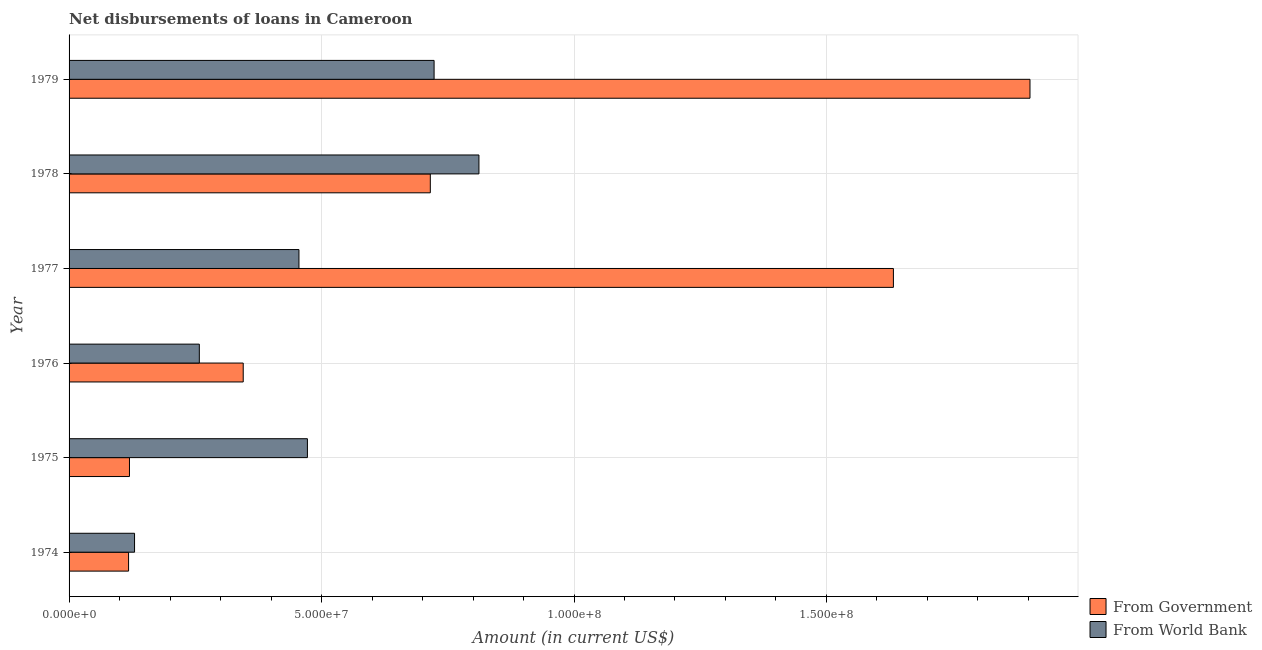How many groups of bars are there?
Provide a short and direct response. 6. Are the number of bars on each tick of the Y-axis equal?
Give a very brief answer. Yes. What is the label of the 1st group of bars from the top?
Your response must be concise. 1979. In how many cases, is the number of bars for a given year not equal to the number of legend labels?
Your answer should be very brief. 0. What is the net disbursements of loan from government in 1975?
Your answer should be compact. 1.20e+07. Across all years, what is the maximum net disbursements of loan from world bank?
Your response must be concise. 8.12e+07. Across all years, what is the minimum net disbursements of loan from government?
Offer a very short reply. 1.18e+07. In which year was the net disbursements of loan from world bank maximum?
Give a very brief answer. 1978. In which year was the net disbursements of loan from world bank minimum?
Your response must be concise. 1974. What is the total net disbursements of loan from government in the graph?
Provide a succinct answer. 4.83e+08. What is the difference between the net disbursements of loan from world bank in 1977 and that in 1979?
Your answer should be compact. -2.68e+07. What is the difference between the net disbursements of loan from government in 1979 and the net disbursements of loan from world bank in 1975?
Provide a succinct answer. 1.43e+08. What is the average net disbursements of loan from government per year?
Make the answer very short. 8.06e+07. In the year 1976, what is the difference between the net disbursements of loan from world bank and net disbursements of loan from government?
Keep it short and to the point. -8.69e+06. What is the ratio of the net disbursements of loan from government in 1975 to that in 1977?
Make the answer very short. 0.07. Is the net disbursements of loan from government in 1975 less than that in 1978?
Offer a terse response. Yes. Is the difference between the net disbursements of loan from government in 1977 and 1979 greater than the difference between the net disbursements of loan from world bank in 1977 and 1979?
Provide a succinct answer. No. What is the difference between the highest and the second highest net disbursements of loan from government?
Make the answer very short. 2.70e+07. What is the difference between the highest and the lowest net disbursements of loan from world bank?
Keep it short and to the point. 6.82e+07. Is the sum of the net disbursements of loan from world bank in 1975 and 1977 greater than the maximum net disbursements of loan from government across all years?
Give a very brief answer. No. What does the 1st bar from the top in 1978 represents?
Your answer should be compact. From World Bank. What does the 1st bar from the bottom in 1976 represents?
Give a very brief answer. From Government. How many bars are there?
Keep it short and to the point. 12. How many years are there in the graph?
Ensure brevity in your answer.  6. Are the values on the major ticks of X-axis written in scientific E-notation?
Keep it short and to the point. Yes. How are the legend labels stacked?
Ensure brevity in your answer.  Vertical. What is the title of the graph?
Ensure brevity in your answer.  Net disbursements of loans in Cameroon. What is the label or title of the Y-axis?
Provide a short and direct response. Year. What is the Amount (in current US$) in From Government in 1974?
Keep it short and to the point. 1.18e+07. What is the Amount (in current US$) of From World Bank in 1974?
Make the answer very short. 1.30e+07. What is the Amount (in current US$) in From Government in 1975?
Offer a terse response. 1.20e+07. What is the Amount (in current US$) in From World Bank in 1975?
Provide a succinct answer. 4.72e+07. What is the Amount (in current US$) of From Government in 1976?
Keep it short and to the point. 3.45e+07. What is the Amount (in current US$) in From World Bank in 1976?
Offer a terse response. 2.58e+07. What is the Amount (in current US$) of From Government in 1977?
Keep it short and to the point. 1.63e+08. What is the Amount (in current US$) in From World Bank in 1977?
Your response must be concise. 4.55e+07. What is the Amount (in current US$) of From Government in 1978?
Ensure brevity in your answer.  7.15e+07. What is the Amount (in current US$) in From World Bank in 1978?
Make the answer very short. 8.12e+07. What is the Amount (in current US$) of From Government in 1979?
Your answer should be very brief. 1.90e+08. What is the Amount (in current US$) of From World Bank in 1979?
Offer a very short reply. 7.23e+07. Across all years, what is the maximum Amount (in current US$) in From Government?
Offer a very short reply. 1.90e+08. Across all years, what is the maximum Amount (in current US$) in From World Bank?
Keep it short and to the point. 8.12e+07. Across all years, what is the minimum Amount (in current US$) in From Government?
Provide a succinct answer. 1.18e+07. Across all years, what is the minimum Amount (in current US$) in From World Bank?
Offer a terse response. 1.30e+07. What is the total Amount (in current US$) in From Government in the graph?
Your answer should be very brief. 4.83e+08. What is the total Amount (in current US$) of From World Bank in the graph?
Ensure brevity in your answer.  2.85e+08. What is the difference between the Amount (in current US$) in From Government in 1974 and that in 1975?
Make the answer very short. -1.77e+05. What is the difference between the Amount (in current US$) in From World Bank in 1974 and that in 1975?
Provide a short and direct response. -3.42e+07. What is the difference between the Amount (in current US$) in From Government in 1974 and that in 1976?
Make the answer very short. -2.27e+07. What is the difference between the Amount (in current US$) in From World Bank in 1974 and that in 1976?
Your answer should be very brief. -1.28e+07. What is the difference between the Amount (in current US$) in From Government in 1974 and that in 1977?
Offer a terse response. -1.51e+08. What is the difference between the Amount (in current US$) in From World Bank in 1974 and that in 1977?
Make the answer very short. -3.26e+07. What is the difference between the Amount (in current US$) in From Government in 1974 and that in 1978?
Offer a terse response. -5.98e+07. What is the difference between the Amount (in current US$) in From World Bank in 1974 and that in 1978?
Offer a terse response. -6.82e+07. What is the difference between the Amount (in current US$) in From Government in 1974 and that in 1979?
Ensure brevity in your answer.  -1.79e+08. What is the difference between the Amount (in current US$) in From World Bank in 1974 and that in 1979?
Keep it short and to the point. -5.93e+07. What is the difference between the Amount (in current US$) in From Government in 1975 and that in 1976?
Ensure brevity in your answer.  -2.25e+07. What is the difference between the Amount (in current US$) of From World Bank in 1975 and that in 1976?
Give a very brief answer. 2.14e+07. What is the difference between the Amount (in current US$) in From Government in 1975 and that in 1977?
Offer a very short reply. -1.51e+08. What is the difference between the Amount (in current US$) of From World Bank in 1975 and that in 1977?
Provide a succinct answer. 1.68e+06. What is the difference between the Amount (in current US$) in From Government in 1975 and that in 1978?
Your answer should be very brief. -5.96e+07. What is the difference between the Amount (in current US$) of From World Bank in 1975 and that in 1978?
Offer a terse response. -3.40e+07. What is the difference between the Amount (in current US$) of From Government in 1975 and that in 1979?
Make the answer very short. -1.78e+08. What is the difference between the Amount (in current US$) in From World Bank in 1975 and that in 1979?
Your answer should be very brief. -2.51e+07. What is the difference between the Amount (in current US$) in From Government in 1976 and that in 1977?
Give a very brief answer. -1.29e+08. What is the difference between the Amount (in current US$) in From World Bank in 1976 and that in 1977?
Make the answer very short. -1.97e+07. What is the difference between the Amount (in current US$) in From Government in 1976 and that in 1978?
Offer a very short reply. -3.71e+07. What is the difference between the Amount (in current US$) of From World Bank in 1976 and that in 1978?
Make the answer very short. -5.54e+07. What is the difference between the Amount (in current US$) in From Government in 1976 and that in 1979?
Your answer should be compact. -1.56e+08. What is the difference between the Amount (in current US$) of From World Bank in 1976 and that in 1979?
Provide a succinct answer. -4.65e+07. What is the difference between the Amount (in current US$) in From Government in 1977 and that in 1978?
Make the answer very short. 9.17e+07. What is the difference between the Amount (in current US$) in From World Bank in 1977 and that in 1978?
Make the answer very short. -3.56e+07. What is the difference between the Amount (in current US$) in From Government in 1977 and that in 1979?
Give a very brief answer. -2.70e+07. What is the difference between the Amount (in current US$) in From World Bank in 1977 and that in 1979?
Keep it short and to the point. -2.68e+07. What is the difference between the Amount (in current US$) in From Government in 1978 and that in 1979?
Provide a succinct answer. -1.19e+08. What is the difference between the Amount (in current US$) of From World Bank in 1978 and that in 1979?
Your answer should be very brief. 8.88e+06. What is the difference between the Amount (in current US$) in From Government in 1974 and the Amount (in current US$) in From World Bank in 1975?
Make the answer very short. -3.54e+07. What is the difference between the Amount (in current US$) of From Government in 1974 and the Amount (in current US$) of From World Bank in 1976?
Your response must be concise. -1.40e+07. What is the difference between the Amount (in current US$) of From Government in 1974 and the Amount (in current US$) of From World Bank in 1977?
Make the answer very short. -3.37e+07. What is the difference between the Amount (in current US$) of From Government in 1974 and the Amount (in current US$) of From World Bank in 1978?
Provide a succinct answer. -6.94e+07. What is the difference between the Amount (in current US$) in From Government in 1974 and the Amount (in current US$) in From World Bank in 1979?
Ensure brevity in your answer.  -6.05e+07. What is the difference between the Amount (in current US$) of From Government in 1975 and the Amount (in current US$) of From World Bank in 1976?
Offer a very short reply. -1.38e+07. What is the difference between the Amount (in current US$) of From Government in 1975 and the Amount (in current US$) of From World Bank in 1977?
Make the answer very short. -3.36e+07. What is the difference between the Amount (in current US$) of From Government in 1975 and the Amount (in current US$) of From World Bank in 1978?
Your response must be concise. -6.92e+07. What is the difference between the Amount (in current US$) in From Government in 1975 and the Amount (in current US$) in From World Bank in 1979?
Make the answer very short. -6.03e+07. What is the difference between the Amount (in current US$) of From Government in 1976 and the Amount (in current US$) of From World Bank in 1977?
Provide a short and direct response. -1.10e+07. What is the difference between the Amount (in current US$) in From Government in 1976 and the Amount (in current US$) in From World Bank in 1978?
Ensure brevity in your answer.  -4.67e+07. What is the difference between the Amount (in current US$) in From Government in 1976 and the Amount (in current US$) in From World Bank in 1979?
Keep it short and to the point. -3.78e+07. What is the difference between the Amount (in current US$) in From Government in 1977 and the Amount (in current US$) in From World Bank in 1978?
Your answer should be very brief. 8.21e+07. What is the difference between the Amount (in current US$) in From Government in 1977 and the Amount (in current US$) in From World Bank in 1979?
Make the answer very short. 9.10e+07. What is the difference between the Amount (in current US$) of From Government in 1978 and the Amount (in current US$) of From World Bank in 1979?
Ensure brevity in your answer.  -7.49e+05. What is the average Amount (in current US$) of From Government per year?
Offer a terse response. 8.06e+07. What is the average Amount (in current US$) of From World Bank per year?
Provide a succinct answer. 4.75e+07. In the year 1974, what is the difference between the Amount (in current US$) of From Government and Amount (in current US$) of From World Bank?
Provide a succinct answer. -1.18e+06. In the year 1975, what is the difference between the Amount (in current US$) in From Government and Amount (in current US$) in From World Bank?
Provide a short and direct response. -3.52e+07. In the year 1976, what is the difference between the Amount (in current US$) of From Government and Amount (in current US$) of From World Bank?
Provide a succinct answer. 8.69e+06. In the year 1977, what is the difference between the Amount (in current US$) in From Government and Amount (in current US$) in From World Bank?
Provide a succinct answer. 1.18e+08. In the year 1978, what is the difference between the Amount (in current US$) in From Government and Amount (in current US$) in From World Bank?
Your answer should be very brief. -9.63e+06. In the year 1979, what is the difference between the Amount (in current US$) in From Government and Amount (in current US$) in From World Bank?
Offer a very short reply. 1.18e+08. What is the ratio of the Amount (in current US$) of From Government in 1974 to that in 1975?
Provide a succinct answer. 0.99. What is the ratio of the Amount (in current US$) in From World Bank in 1974 to that in 1975?
Your answer should be compact. 0.27. What is the ratio of the Amount (in current US$) of From Government in 1974 to that in 1976?
Provide a succinct answer. 0.34. What is the ratio of the Amount (in current US$) in From World Bank in 1974 to that in 1976?
Give a very brief answer. 0.5. What is the ratio of the Amount (in current US$) in From Government in 1974 to that in 1977?
Your answer should be compact. 0.07. What is the ratio of the Amount (in current US$) of From World Bank in 1974 to that in 1977?
Your response must be concise. 0.28. What is the ratio of the Amount (in current US$) in From Government in 1974 to that in 1978?
Keep it short and to the point. 0.16. What is the ratio of the Amount (in current US$) in From World Bank in 1974 to that in 1978?
Provide a succinct answer. 0.16. What is the ratio of the Amount (in current US$) of From Government in 1974 to that in 1979?
Provide a succinct answer. 0.06. What is the ratio of the Amount (in current US$) in From World Bank in 1974 to that in 1979?
Offer a terse response. 0.18. What is the ratio of the Amount (in current US$) in From Government in 1975 to that in 1976?
Offer a very short reply. 0.35. What is the ratio of the Amount (in current US$) of From World Bank in 1975 to that in 1976?
Give a very brief answer. 1.83. What is the ratio of the Amount (in current US$) in From Government in 1975 to that in 1977?
Your answer should be very brief. 0.07. What is the ratio of the Amount (in current US$) of From World Bank in 1975 to that in 1977?
Give a very brief answer. 1.04. What is the ratio of the Amount (in current US$) of From Government in 1975 to that in 1978?
Your answer should be very brief. 0.17. What is the ratio of the Amount (in current US$) of From World Bank in 1975 to that in 1978?
Your response must be concise. 0.58. What is the ratio of the Amount (in current US$) of From Government in 1975 to that in 1979?
Provide a succinct answer. 0.06. What is the ratio of the Amount (in current US$) of From World Bank in 1975 to that in 1979?
Give a very brief answer. 0.65. What is the ratio of the Amount (in current US$) of From Government in 1976 to that in 1977?
Give a very brief answer. 0.21. What is the ratio of the Amount (in current US$) of From World Bank in 1976 to that in 1977?
Give a very brief answer. 0.57. What is the ratio of the Amount (in current US$) in From Government in 1976 to that in 1978?
Your answer should be very brief. 0.48. What is the ratio of the Amount (in current US$) of From World Bank in 1976 to that in 1978?
Offer a terse response. 0.32. What is the ratio of the Amount (in current US$) of From Government in 1976 to that in 1979?
Ensure brevity in your answer.  0.18. What is the ratio of the Amount (in current US$) in From World Bank in 1976 to that in 1979?
Give a very brief answer. 0.36. What is the ratio of the Amount (in current US$) in From Government in 1977 to that in 1978?
Provide a succinct answer. 2.28. What is the ratio of the Amount (in current US$) of From World Bank in 1977 to that in 1978?
Your answer should be very brief. 0.56. What is the ratio of the Amount (in current US$) of From Government in 1977 to that in 1979?
Provide a succinct answer. 0.86. What is the ratio of the Amount (in current US$) in From World Bank in 1977 to that in 1979?
Provide a succinct answer. 0.63. What is the ratio of the Amount (in current US$) of From Government in 1978 to that in 1979?
Provide a short and direct response. 0.38. What is the ratio of the Amount (in current US$) of From World Bank in 1978 to that in 1979?
Offer a very short reply. 1.12. What is the difference between the highest and the second highest Amount (in current US$) of From Government?
Give a very brief answer. 2.70e+07. What is the difference between the highest and the second highest Amount (in current US$) in From World Bank?
Make the answer very short. 8.88e+06. What is the difference between the highest and the lowest Amount (in current US$) in From Government?
Provide a succinct answer. 1.79e+08. What is the difference between the highest and the lowest Amount (in current US$) of From World Bank?
Offer a very short reply. 6.82e+07. 